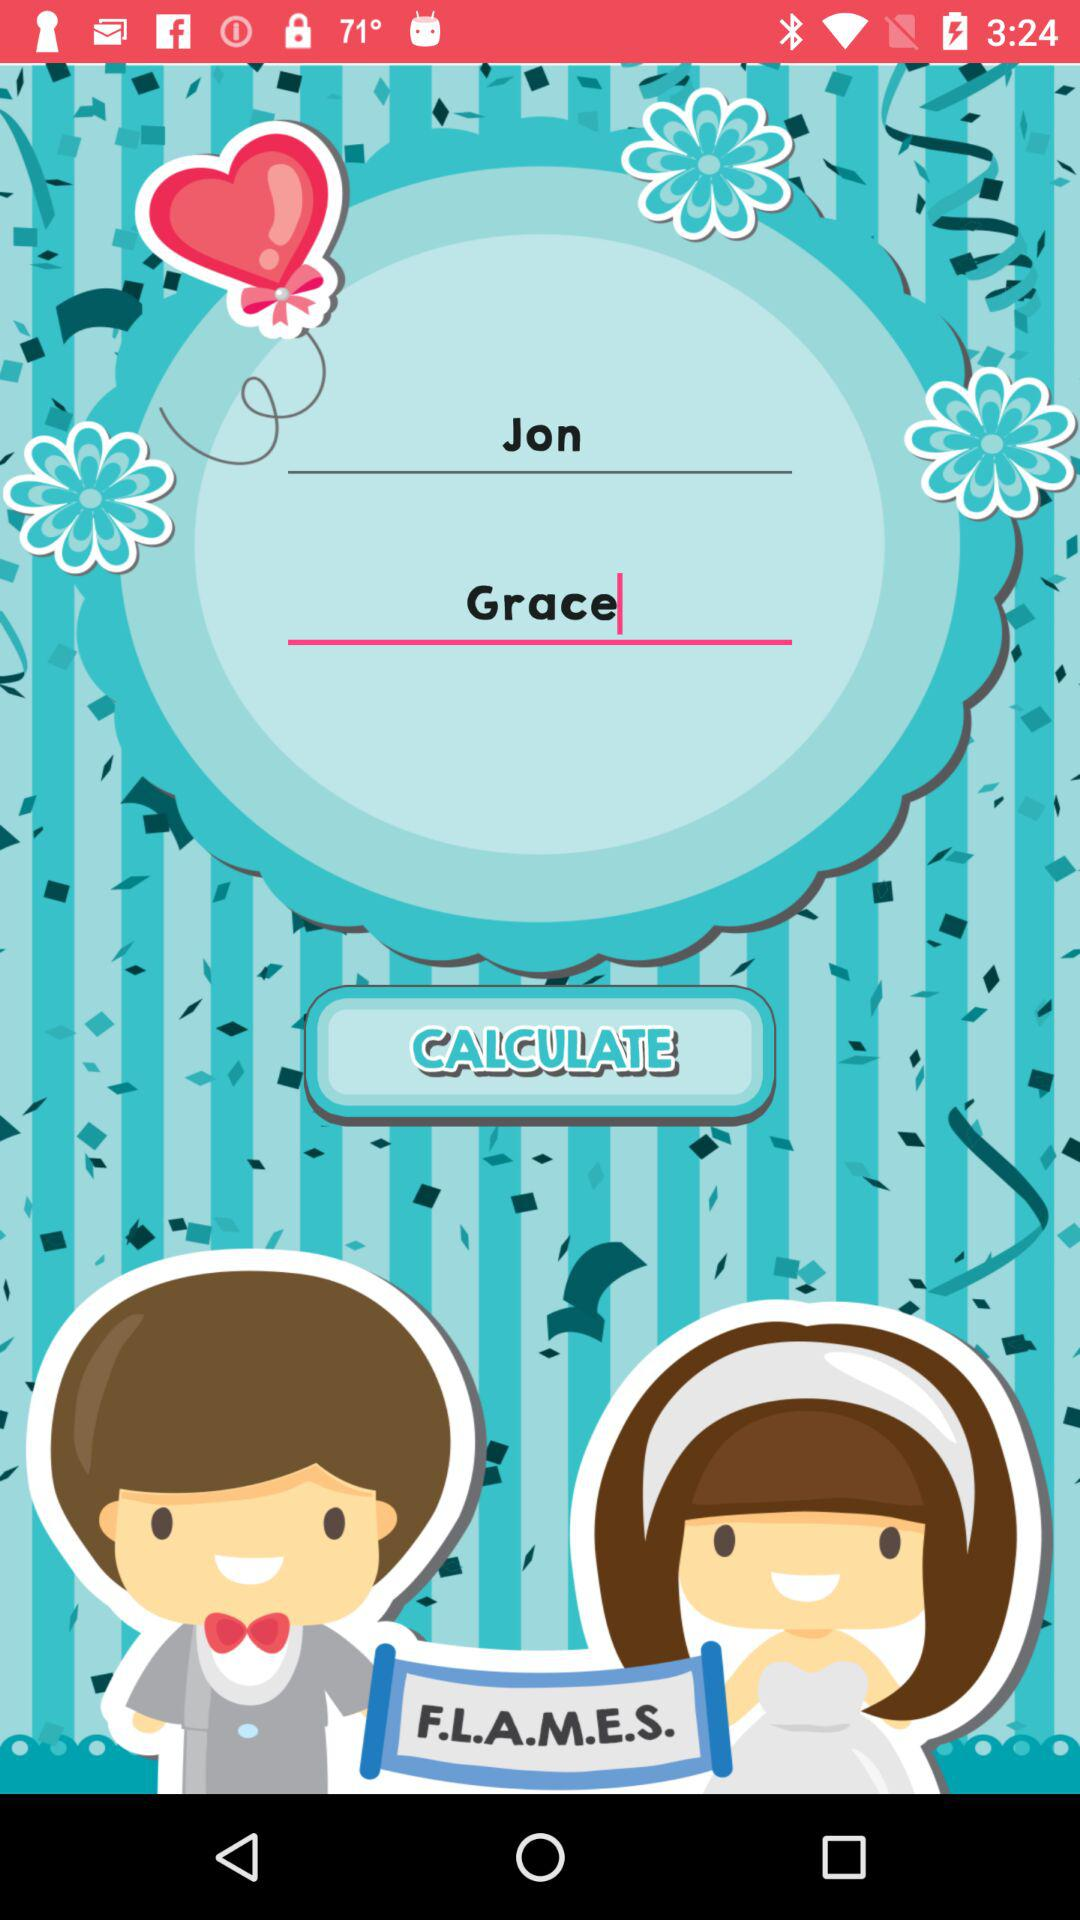What is the name of the boy? The name of the boy is Jon. 